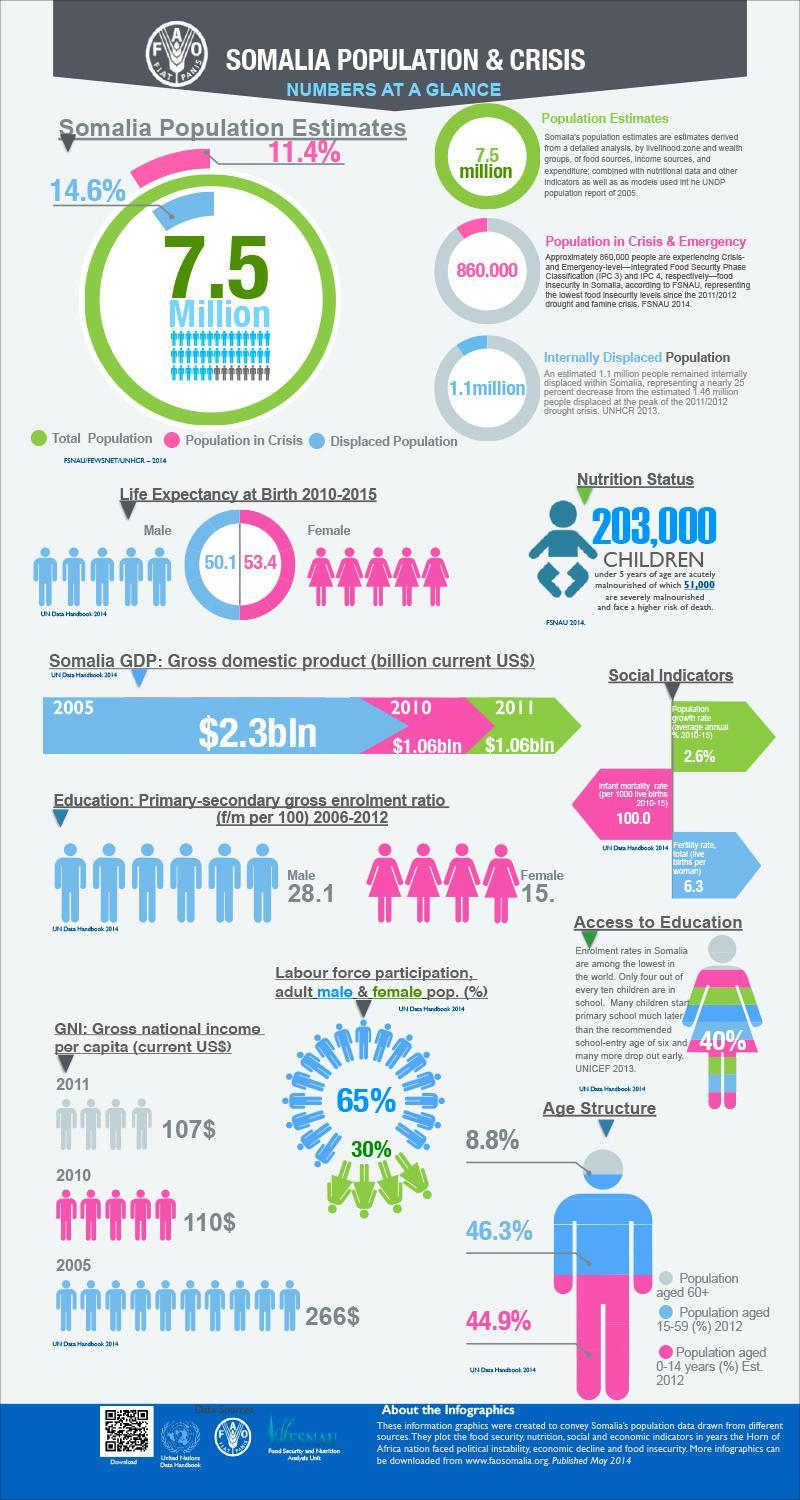What is the percentage of the population in the age group of 60+ and 15-59, taken together?
Answer the question with a short phrase. 55.1% What is the percentage of the population in the age group of 60+ and 0-14 taken together? 53.7% What is the percentage of enrollment of females in Somalia? 40% 